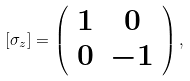Convert formula to latex. <formula><loc_0><loc_0><loc_500><loc_500>[ \sigma _ { z } ] = \left ( \begin{array} { c c } 1 & 0 \\ 0 & - 1 \end{array} \right ) ,</formula> 